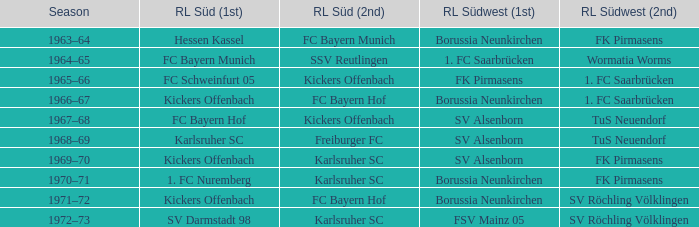Who was RL Süd (1st) when FK Pirmasens was RL Südwest (1st)? FC Schweinfurt 05. 